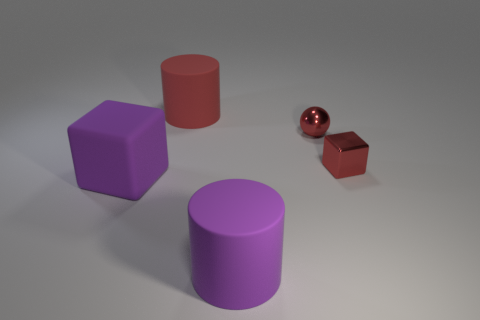What material is the cube that is the same color as the metallic sphere?
Ensure brevity in your answer.  Metal. There is a big matte thing behind the small shiny object that is behind the small red block; what color is it?
Offer a terse response. Red. Do the red metal block and the red ball have the same size?
Make the answer very short. Yes. There is a large purple object that is the same shape as the large red rubber thing; what is its material?
Offer a terse response. Rubber. How many blue metal things are the same size as the purple cylinder?
Give a very brief answer. 0. The block that is made of the same material as the big red thing is what color?
Ensure brevity in your answer.  Purple. Are there fewer small objects than brown rubber cylinders?
Offer a terse response. No. What number of gray objects are either metal balls or metal objects?
Provide a succinct answer. 0. What number of matte objects are behind the red cube and in front of the large purple rubber block?
Your response must be concise. 0. Does the tiny red sphere have the same material as the purple block?
Your answer should be compact. No. 